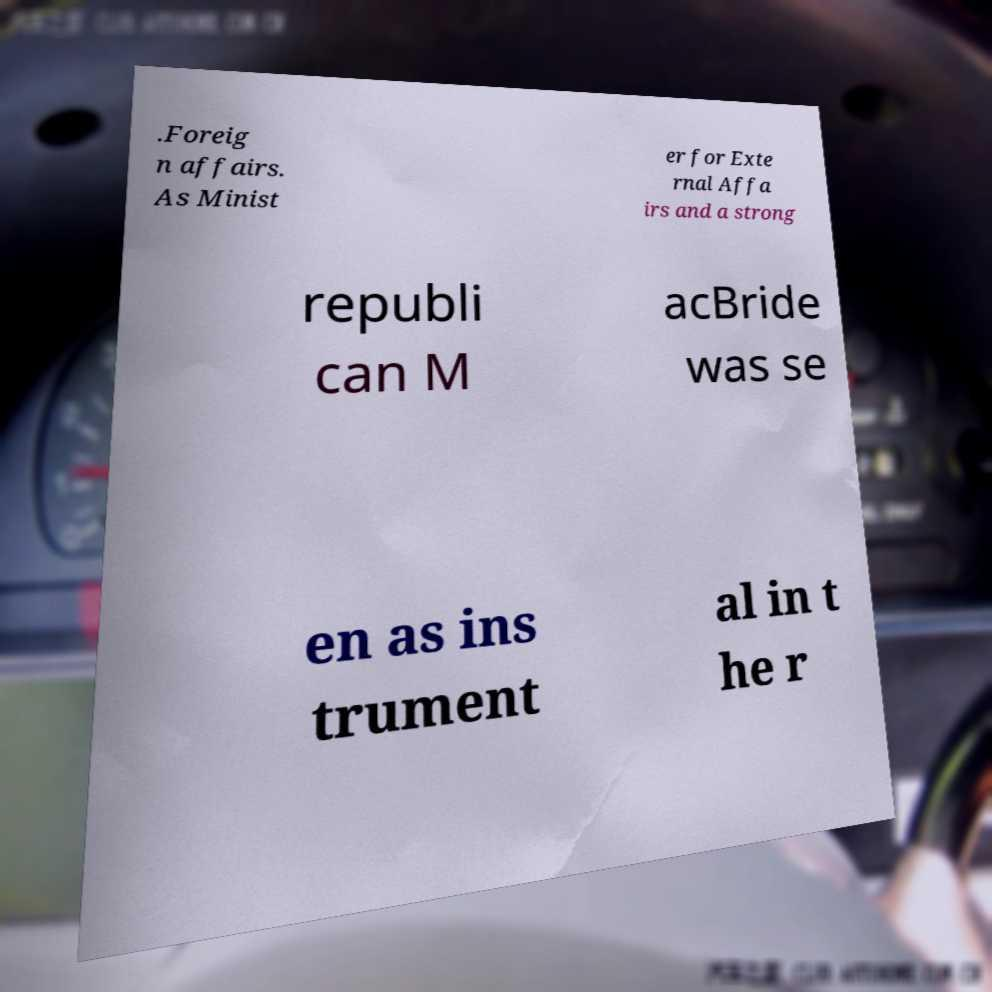For documentation purposes, I need the text within this image transcribed. Could you provide that? .Foreig n affairs. As Minist er for Exte rnal Affa irs and a strong republi can M acBride was se en as ins trument al in t he r 